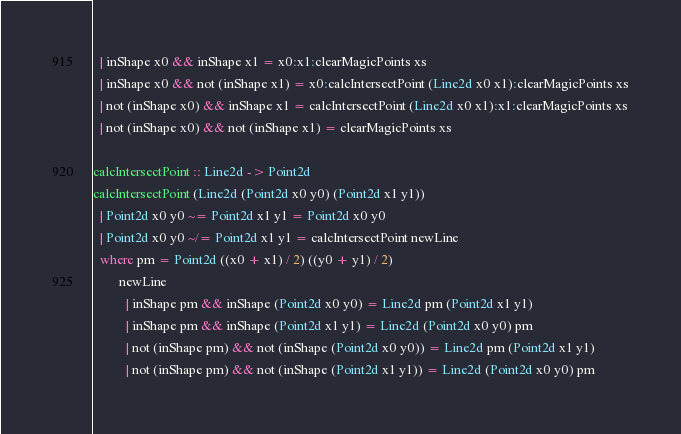Convert code to text. <code><loc_0><loc_0><loc_500><loc_500><_Haskell_>  | inShape x0 && inShape x1 = x0:x1:clearMagicPoints xs
  | inShape x0 && not (inShape x1) = x0:calcIntersectPoint (Line2d x0 x1):clearMagicPoints xs
  | not (inShape x0) && inShape x1 = calcIntersectPoint (Line2d x0 x1):x1:clearMagicPoints xs
  | not (inShape x0) && not (inShape x1) = clearMagicPoints xs

calcIntersectPoint :: Line2d -> Point2d
calcIntersectPoint (Line2d (Point2d x0 y0) (Point2d x1 y1))
  | Point2d x0 y0 ~= Point2d x1 y1 = Point2d x0 y0
  | Point2d x0 y0 ~/= Point2d x1 y1 = calcIntersectPoint newLine
  where pm = Point2d ((x0 + x1) / 2) ((y0 + y1) / 2)
        newLine
          | inShape pm && inShape (Point2d x0 y0) = Line2d pm (Point2d x1 y1)
          | inShape pm && inShape (Point2d x1 y1) = Line2d (Point2d x0 y0) pm
          | not (inShape pm) && not (inShape (Point2d x0 y0)) = Line2d pm (Point2d x1 y1)
          | not (inShape pm) && not (inShape (Point2d x1 y1)) = Line2d (Point2d x0 y0) pm</code> 